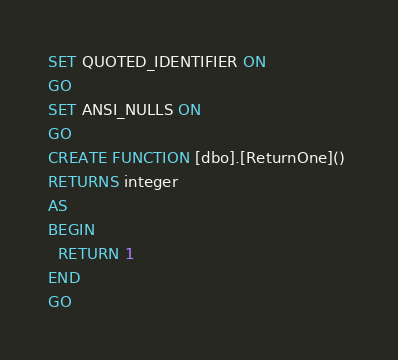Convert code to text. <code><loc_0><loc_0><loc_500><loc_500><_SQL_>SET QUOTED_IDENTIFIER ON
GO
SET ANSI_NULLS ON
GO
CREATE FUNCTION [dbo].[ReturnOne]() 
RETURNS integer
AS
BEGIN
  RETURN 1
END
GO</code> 